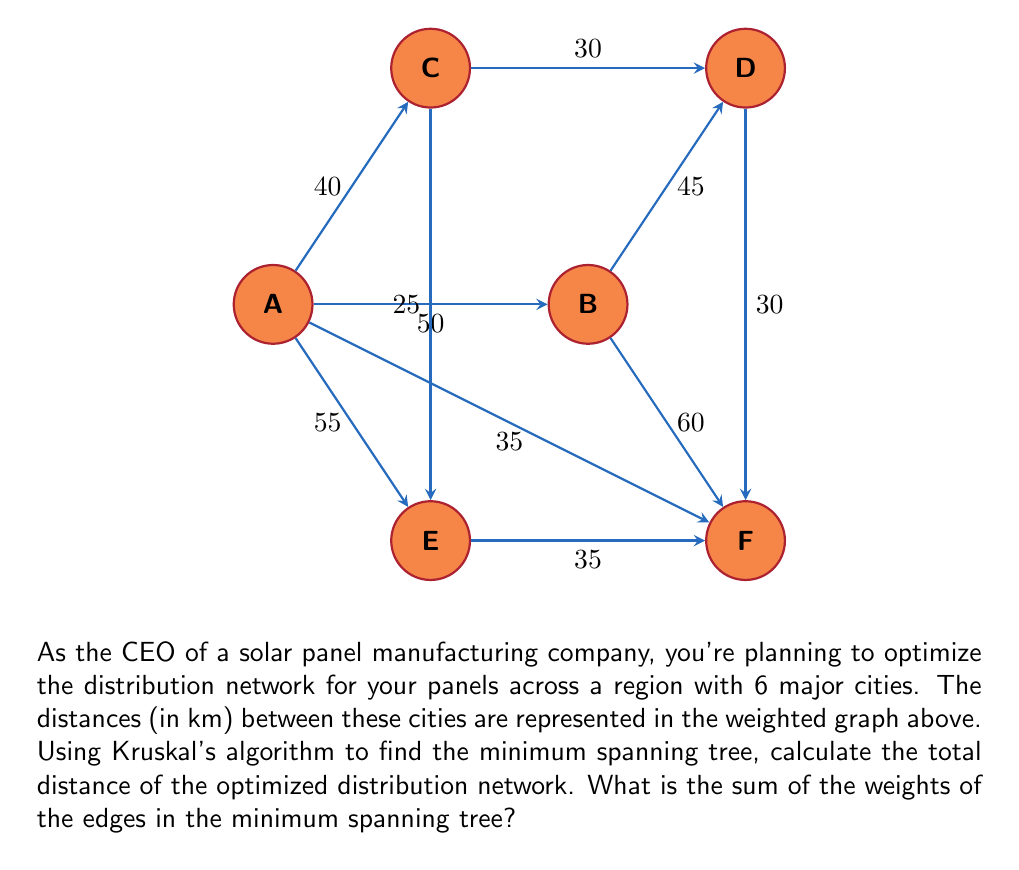Teach me how to tackle this problem. To solve this problem using Kruskal's algorithm, we'll follow these steps:

1) First, list all edges with their weights in ascending order:
   C-E: 25
   C-D: 30
   D-F: 30
   E-F: 35
   A-C: 40
   B-D: 45
   A-B: 50
   A-E: 55
   B-F: 60
   A-F: 35

2) Start with an empty set of edges and add edges one by one, ensuring no cycles are formed:

   - Add C-E (25)
   - Add C-D (30)
   - Add D-F (30)
   - Add E-F (35) - This would form a cycle, so skip
   - Add A-C (40)
   - Add B-D (45)

3) At this point, we have 5 edges connecting all 6 vertices, so we stop.

4) The minimum spanning tree consists of these edges:
   C-E (25)
   C-D (30)
   D-F (30)
   A-C (40)
   B-D (45)

5) To get the total distance, sum the weights of these edges:

   $$25 + 30 + 30 + 40 + 45 = 170$$

Therefore, the total distance of the optimized distribution network is 170 km.
Answer: 170 km 